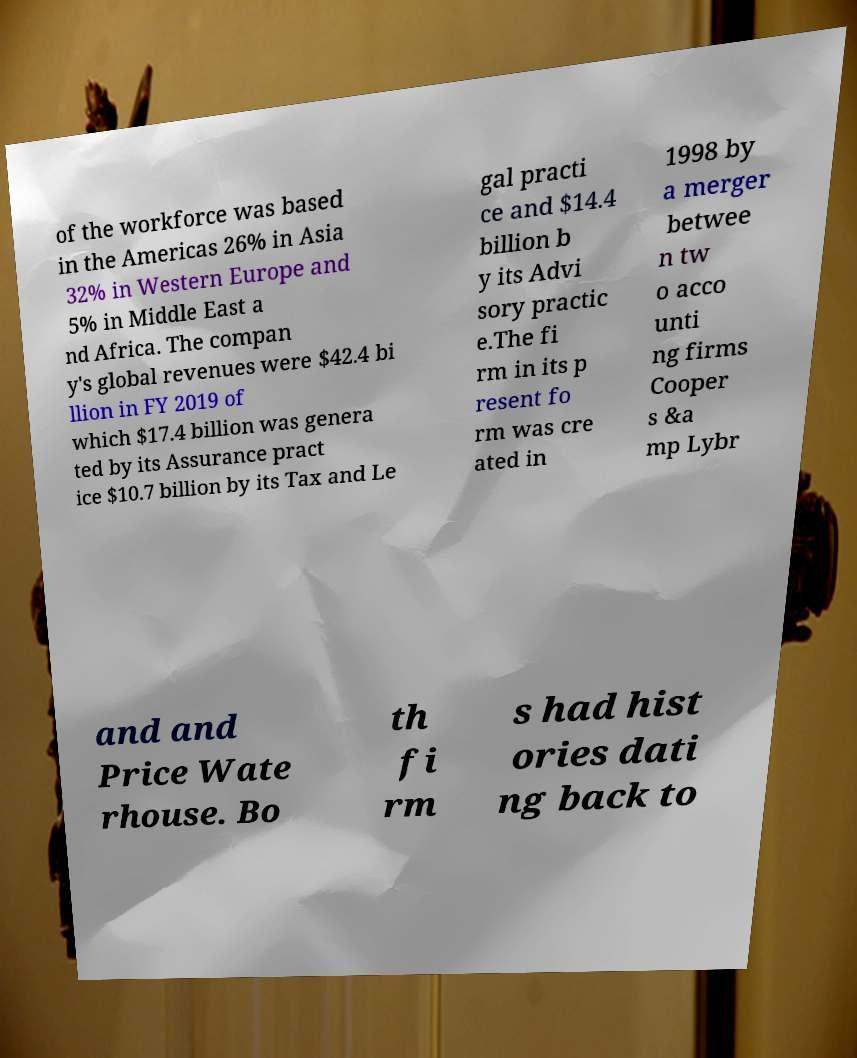For documentation purposes, I need the text within this image transcribed. Could you provide that? of the workforce was based in the Americas 26% in Asia 32% in Western Europe and 5% in Middle East a nd Africa. The compan y's global revenues were $42.4 bi llion in FY 2019 of which $17.4 billion was genera ted by its Assurance pract ice $10.7 billion by its Tax and Le gal practi ce and $14.4 billion b y its Advi sory practic e.The fi rm in its p resent fo rm was cre ated in 1998 by a merger betwee n tw o acco unti ng firms Cooper s &a mp Lybr and and Price Wate rhouse. Bo th fi rm s had hist ories dati ng back to 